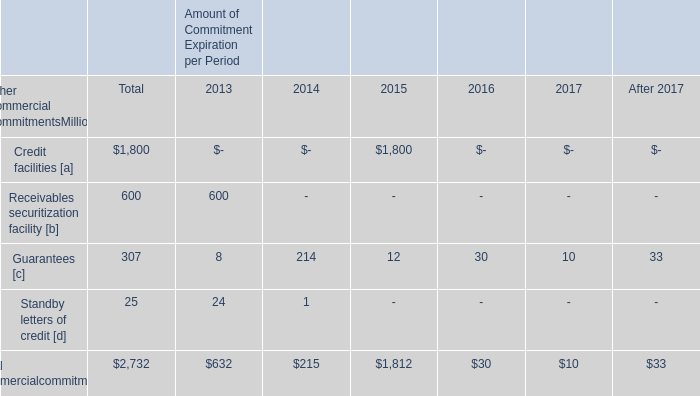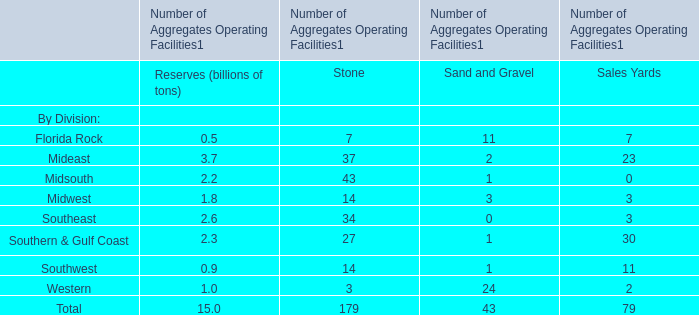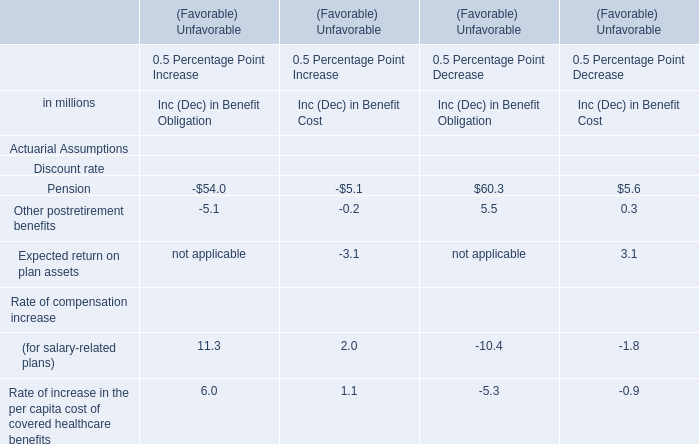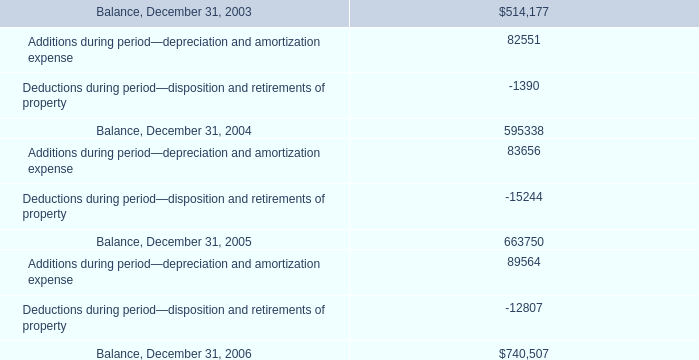What was the average value of MidsouthMidwestSoutheast for Reserves (in billion) 
Computations: (((2.2 + 1.8) + 2.6) / 3)
Answer: 2.2. 